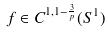Convert formula to latex. <formula><loc_0><loc_0><loc_500><loc_500>f \in C ^ { 1 , 1 - \frac { 3 } { p } } ( S ^ { 1 } )</formula> 